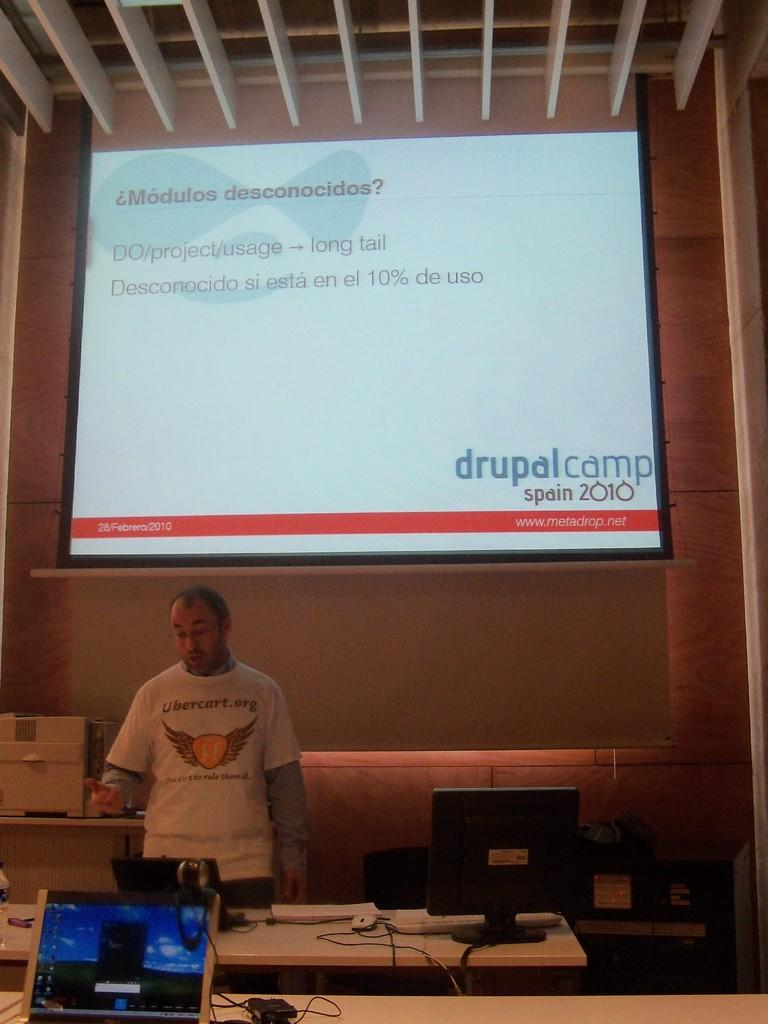What is the man in the image doing? The man is standing in the image. What electronic devices are visible in the image? There is a laptop, keyboard, and mouse in the image. What type of machine is present in the image? There is a machine in the image. What is the primary output device in the image? There is a screen in the image. Can you describe the behavior of the cactus in the image? There is no cactus present in the image, so it is not possible to describe its behavior. 